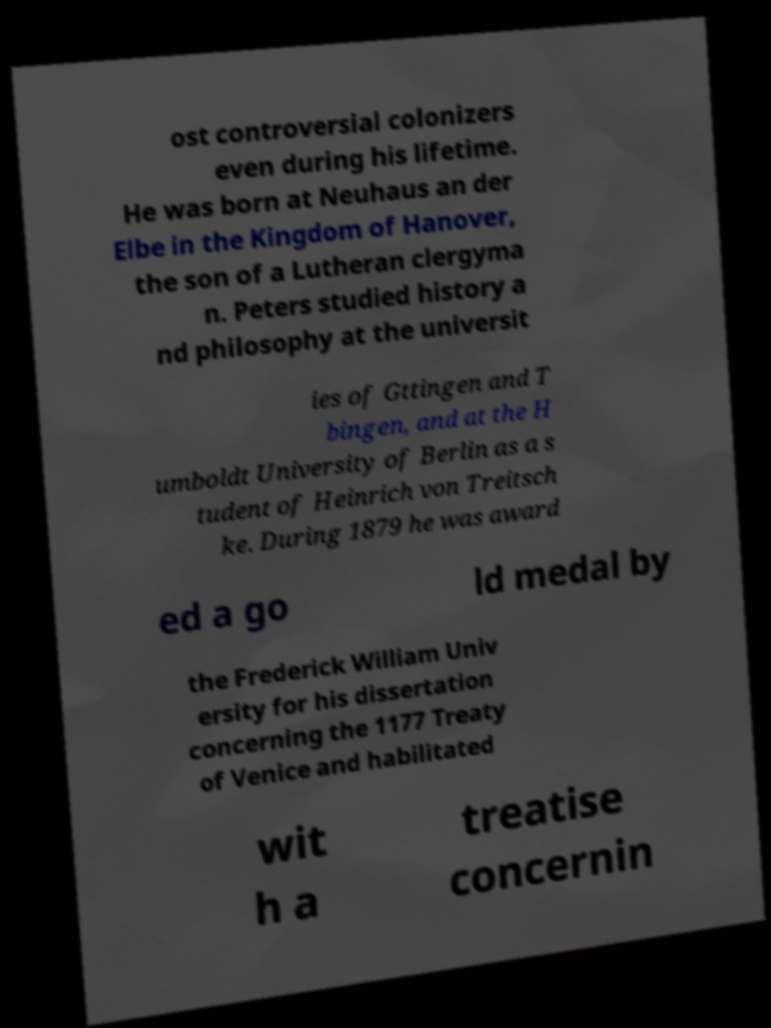What messages or text are displayed in this image? I need them in a readable, typed format. ost controversial colonizers even during his lifetime. He was born at Neuhaus an der Elbe in the Kingdom of Hanover, the son of a Lutheran clergyma n. Peters studied history a nd philosophy at the universit ies of Gttingen and T bingen, and at the H umboldt University of Berlin as a s tudent of Heinrich von Treitsch ke. During 1879 he was award ed a go ld medal by the Frederick William Univ ersity for his dissertation concerning the 1177 Treaty of Venice and habilitated wit h a treatise concernin 